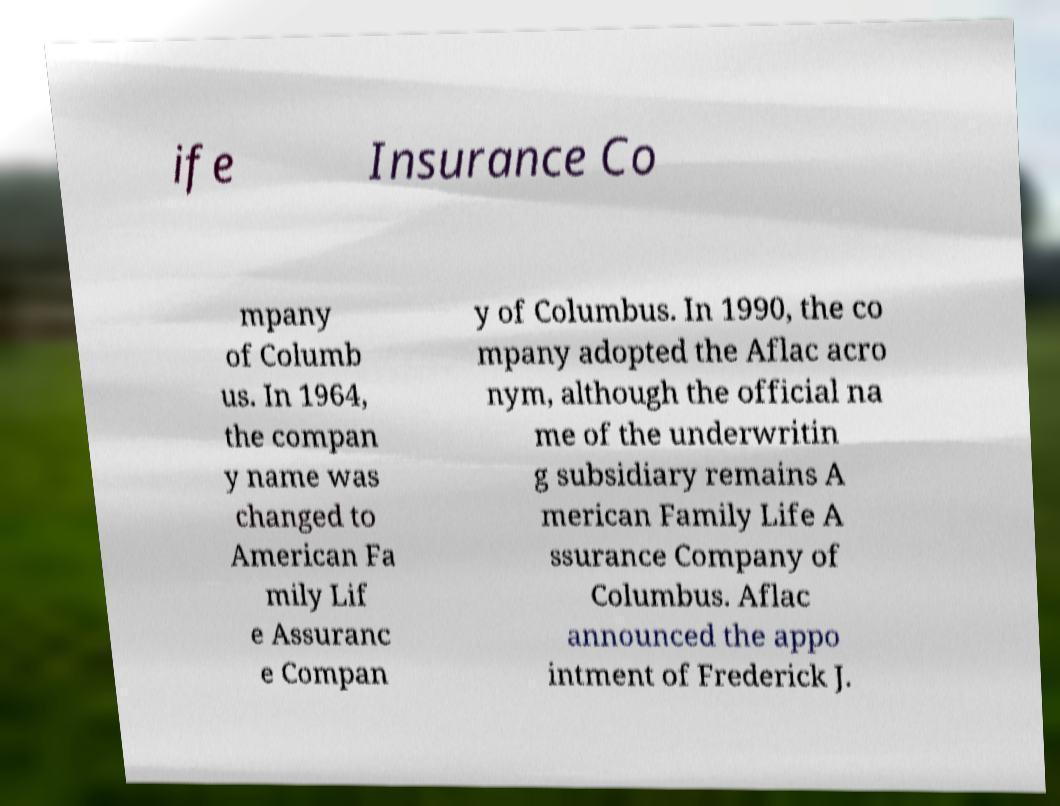Can you accurately transcribe the text from the provided image for me? ife Insurance Co mpany of Columb us. In 1964, the compan y name was changed to American Fa mily Lif e Assuranc e Compan y of Columbus. In 1990, the co mpany adopted the Aflac acro nym, although the official na me of the underwritin g subsidiary remains A merican Family Life A ssurance Company of Columbus. Aflac announced the appo intment of Frederick J. 